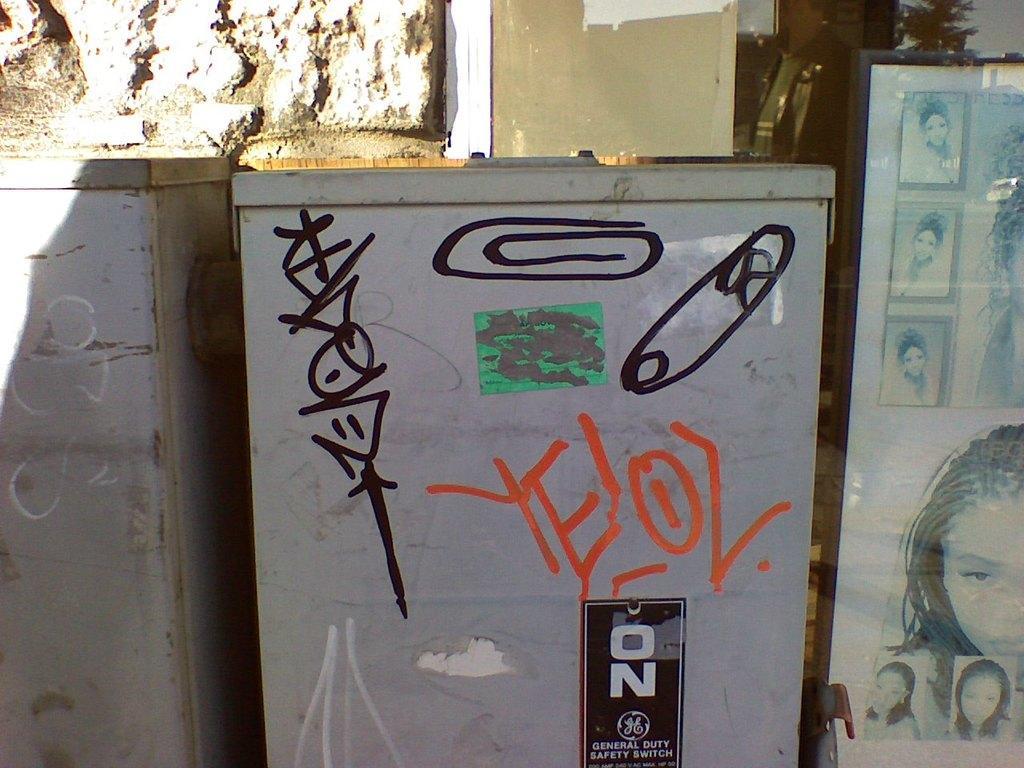Describe this image in one or two sentences. In the picture I can see metal boxes and a glass wall. On the right side of the image I can see photos of women. 